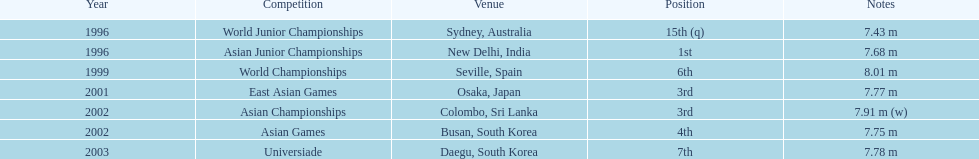In which single event did this participant secure the first position? Asian Junior Championships. 